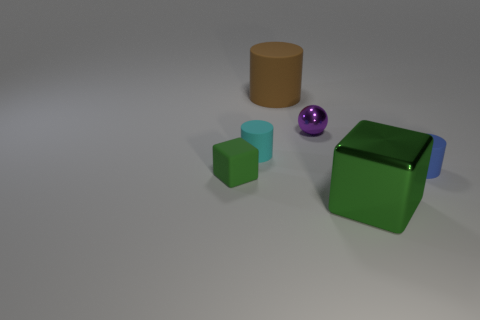Subtract all small cylinders. How many cylinders are left? 1 Add 1 purple metallic objects. How many objects exist? 7 Subtract all balls. How many objects are left? 5 Add 3 cyan balls. How many cyan balls exist? 3 Subtract 2 green cubes. How many objects are left? 4 Subtract all large green shiny cubes. Subtract all rubber blocks. How many objects are left? 4 Add 3 tiny cyan cylinders. How many tiny cyan cylinders are left? 4 